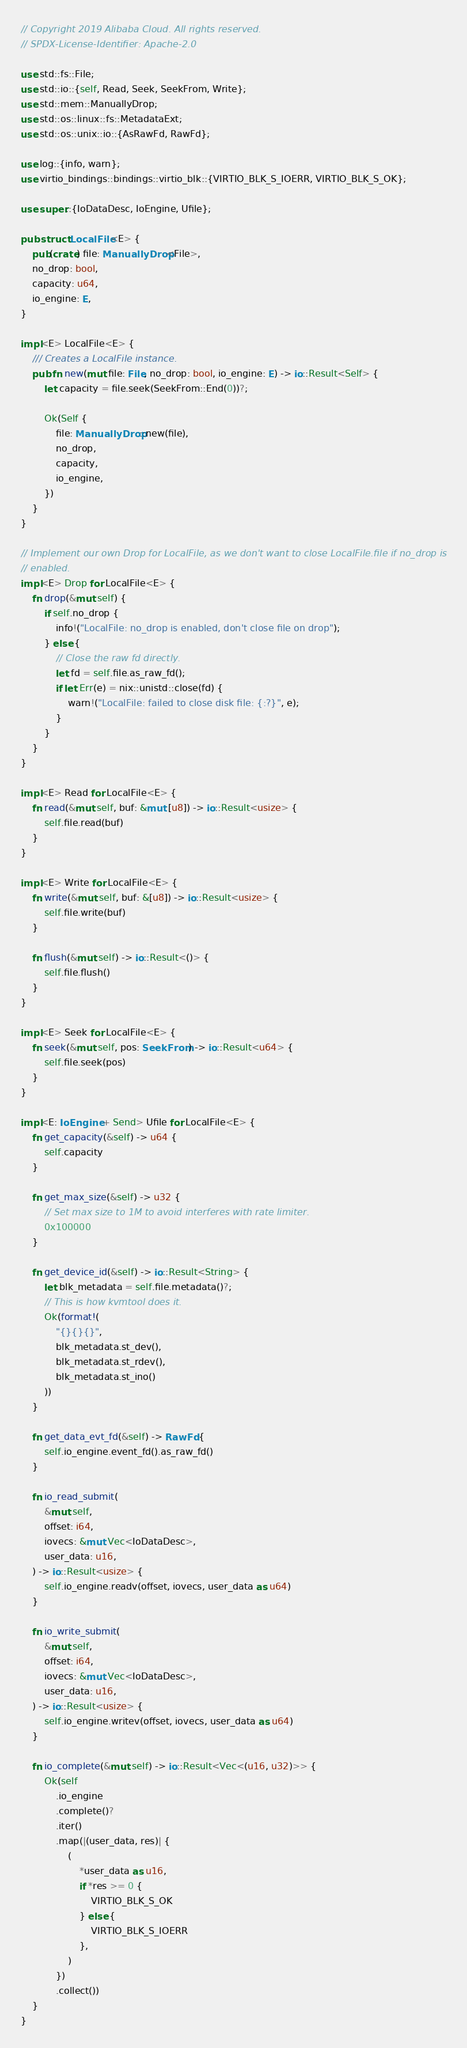Convert code to text. <code><loc_0><loc_0><loc_500><loc_500><_Rust_>// Copyright 2019 Alibaba Cloud. All rights reserved.
// SPDX-License-Identifier: Apache-2.0

use std::fs::File;
use std::io::{self, Read, Seek, SeekFrom, Write};
use std::mem::ManuallyDrop;
use std::os::linux::fs::MetadataExt;
use std::os::unix::io::{AsRawFd, RawFd};

use log::{info, warn};
use virtio_bindings::bindings::virtio_blk::{VIRTIO_BLK_S_IOERR, VIRTIO_BLK_S_OK};

use super::{IoDataDesc, IoEngine, Ufile};

pub struct LocalFile<E> {
    pub(crate) file: ManuallyDrop<File>,
    no_drop: bool,
    capacity: u64,
    io_engine: E,
}

impl<E> LocalFile<E> {
    /// Creates a LocalFile instance.
    pub fn new(mut file: File, no_drop: bool, io_engine: E) -> io::Result<Self> {
        let capacity = file.seek(SeekFrom::End(0))?;

        Ok(Self {
            file: ManuallyDrop::new(file),
            no_drop,
            capacity,
            io_engine,
        })
    }
}

// Implement our own Drop for LocalFile, as we don't want to close LocalFile.file if no_drop is
// enabled.
impl<E> Drop for LocalFile<E> {
    fn drop(&mut self) {
        if self.no_drop {
            info!("LocalFile: no_drop is enabled, don't close file on drop");
        } else {
            // Close the raw fd directly.
            let fd = self.file.as_raw_fd();
            if let Err(e) = nix::unistd::close(fd) {
                warn!("LocalFile: failed to close disk file: {:?}", e);
            }
        }
    }
}

impl<E> Read for LocalFile<E> {
    fn read(&mut self, buf: &mut [u8]) -> io::Result<usize> {
        self.file.read(buf)
    }
}

impl<E> Write for LocalFile<E> {
    fn write(&mut self, buf: &[u8]) -> io::Result<usize> {
        self.file.write(buf)
    }

    fn flush(&mut self) -> io::Result<()> {
        self.file.flush()
    }
}

impl<E> Seek for LocalFile<E> {
    fn seek(&mut self, pos: SeekFrom) -> io::Result<u64> {
        self.file.seek(pos)
    }
}

impl<E: IoEngine + Send> Ufile for LocalFile<E> {
    fn get_capacity(&self) -> u64 {
        self.capacity
    }

    fn get_max_size(&self) -> u32 {
        // Set max size to 1M to avoid interferes with rate limiter.
        0x100000
    }

    fn get_device_id(&self) -> io::Result<String> {
        let blk_metadata = self.file.metadata()?;
        // This is how kvmtool does it.
        Ok(format!(
            "{}{}{}",
            blk_metadata.st_dev(),
            blk_metadata.st_rdev(),
            blk_metadata.st_ino()
        ))
    }

    fn get_data_evt_fd(&self) -> RawFd {
        self.io_engine.event_fd().as_raw_fd()
    }

    fn io_read_submit(
        &mut self,
        offset: i64,
        iovecs: &mut Vec<IoDataDesc>,
        user_data: u16,
    ) -> io::Result<usize> {
        self.io_engine.readv(offset, iovecs, user_data as u64)
    }

    fn io_write_submit(
        &mut self,
        offset: i64,
        iovecs: &mut Vec<IoDataDesc>,
        user_data: u16,
    ) -> io::Result<usize> {
        self.io_engine.writev(offset, iovecs, user_data as u64)
    }

    fn io_complete(&mut self) -> io::Result<Vec<(u16, u32)>> {
        Ok(self
            .io_engine
            .complete()?
            .iter()
            .map(|(user_data, res)| {
                (
                    *user_data as u16,
                    if *res >= 0 {
                        VIRTIO_BLK_S_OK
                    } else {
                        VIRTIO_BLK_S_IOERR
                    },
                )
            })
            .collect())
    }
}
</code> 